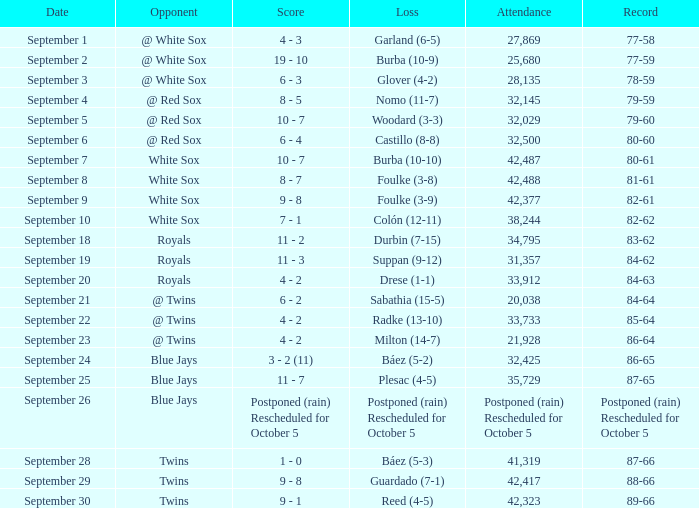What is the record of the game with 28,135 people in attendance? 78-59. 